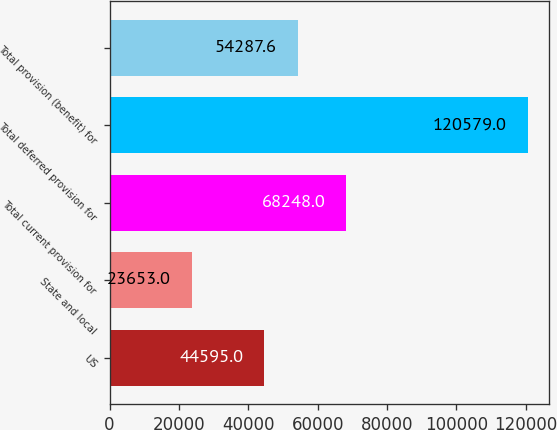Convert chart. <chart><loc_0><loc_0><loc_500><loc_500><bar_chart><fcel>US<fcel>State and local<fcel>Total current provision for<fcel>Total deferred provision for<fcel>Total provision (benefit) for<nl><fcel>44595<fcel>23653<fcel>68248<fcel>120579<fcel>54287.6<nl></chart> 